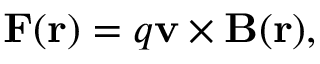<formula> <loc_0><loc_0><loc_500><loc_500>F ( r ) = q v \times B ( r ) ,</formula> 